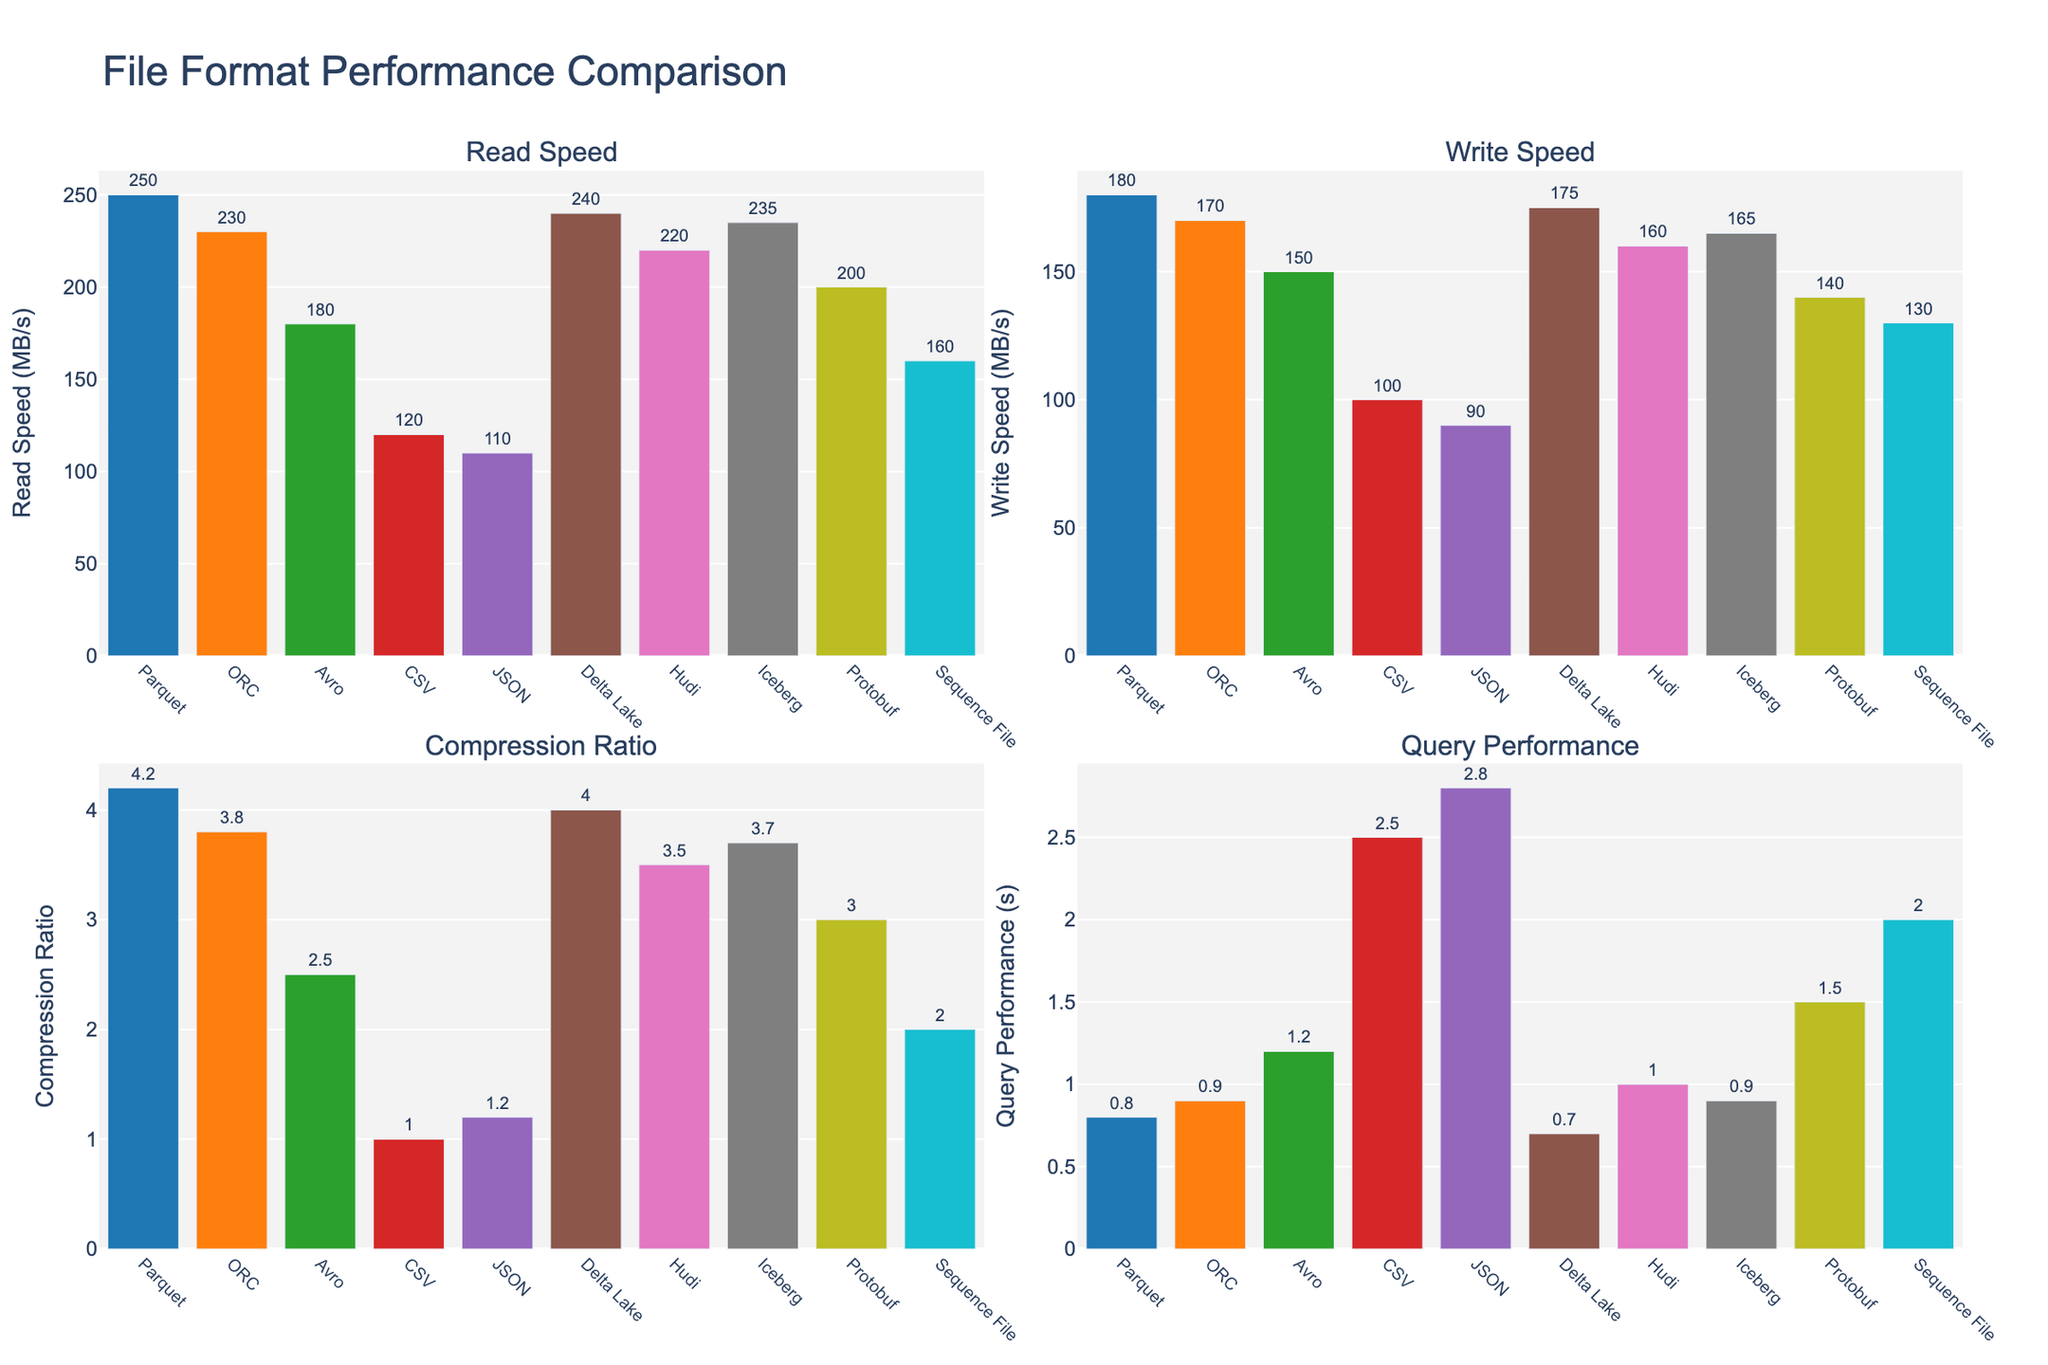Which file format has the highest read speed? The highest bar in the "Read Speed" chart represents the file format with the highest read speed. Parquet has the highest read speed at 250 MB/s.
Answer: Parquet What is the difference in write speed between Avro and JSON? Look at the "Write Speed" chart to find the heights of the bars for Avro and JSON. Avro has a write speed of 150 MB/s, and JSON has a write speed of 90 MB/s. The difference is 150 - 90 = 60 MB/s.
Answer: 60 MB/s Which file format has the best query performance? In the "Query Performance" chart, the shortest bar represents the best query performance. Delta Lake has the best query performance at 0.7 seconds.
Answer: Delta Lake How much higher is the compression ratio of Parquet compared to CSV? Check the heights of the bars in the "Compression Ratio" chart. Parquet has a compression ratio of 4.2, and CSV has a compression ratio of 1.0. The difference is 4.2 - 1.0 = 3.2.
Answer: 3.2 Which file format has the lowest read speed? The shortest bar in the "Read Speed" chart indicates the file format with the lowest read speed. JSON has the lowest read speed at 110 MB/s.
Answer: JSON Rank the file formats based on write speed from highest to lowest. Order the file formats according to the heights of their bars in the "Write Speed" chart. The order is: Parquet, Delta Lake, ORC, Iceberg, Hudi, Avro, Protobuf, Sequence File, CSV, JSON.
Answer: Parquet, Delta Lake, ORC, Iceberg, Hudi, Avro, Protobuf, Sequence File, CSV, JSON What is the average query performance across all file formats? Add the query performance times from the "Query Performance" chart and divide by the number of file formats. (0.8 + 0.9 + 1.2 + 2.5 + 2.8 + 0.7 + 1.0 + 0.9 + 1.5 + 2.0) / 10 = 1.43 seconds.
Answer: 1.43 seconds Is there any file format that performs better than both Parquet and ORC in read speed, write speed, and query performance? Compare the read speed, write speed, and query performance bars for each file format against those of Parquet and ORC. Delta Lake has a read speed of 240 MB/s, a write speed of 175 MB/s, and a query performance time of 0.7 seconds, performing better overall compared to Parquet and ORC.
Answer: Delta Lake Which two file formats have similar query performance times? Look for bars of similar height in the "Query Performance" chart. ORC and Iceberg both have query performance times of 0.9 seconds.
Answer: ORC and Iceberg What is the sum of read speeds for Protobuf and Sequence File? Add the read speeds from the "Read Speed" chart for Protobuf and Sequence File. Protobuf has a read speed of 200 MB/s and Sequence File has 160 MB/s. The sum is 200 + 160 = 360 MB/s.
Answer: 360 MB/s 